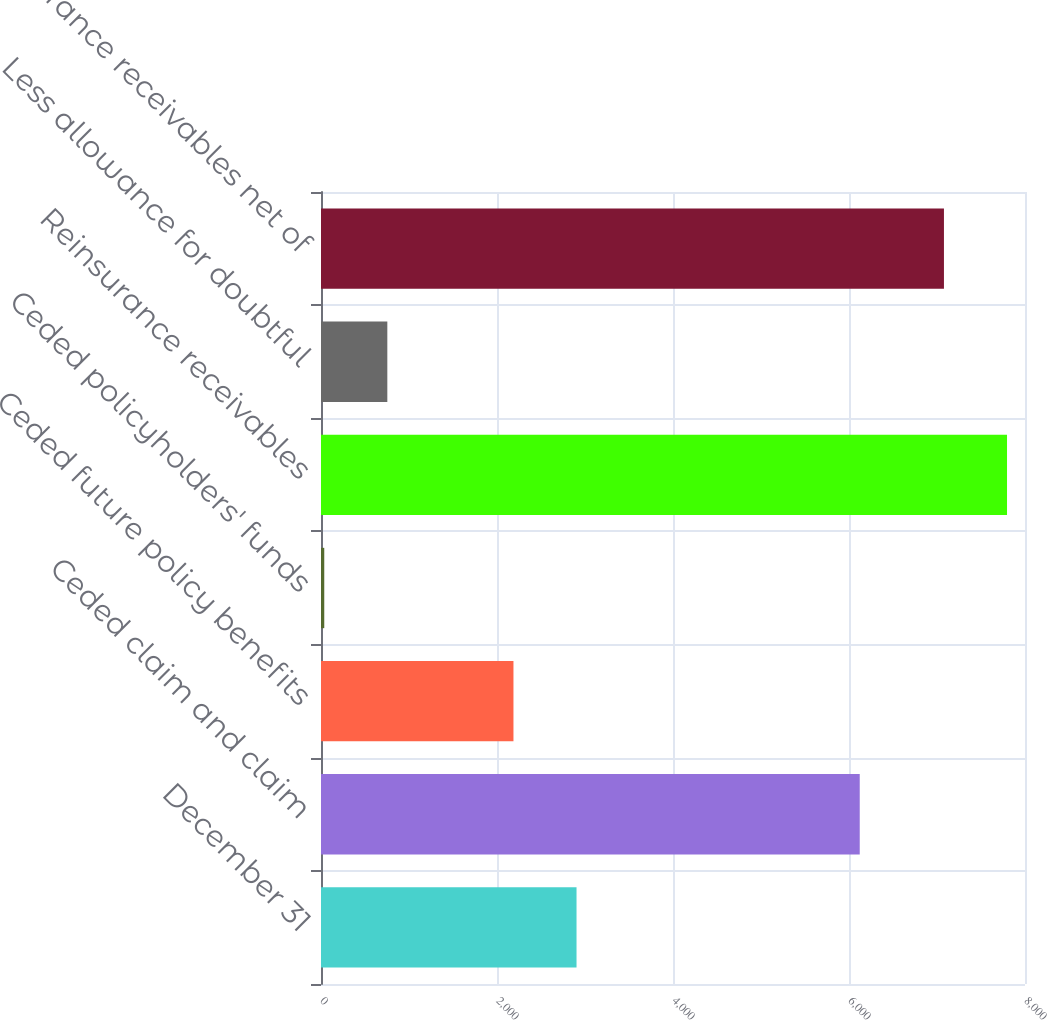Convert chart to OTSL. <chart><loc_0><loc_0><loc_500><loc_500><bar_chart><fcel>December 31<fcel>Ceded claim and claim<fcel>Ceded future policy benefits<fcel>Ceded policyholders' funds<fcel>Reinsurance receivables<fcel>Less allowance for doubtful<fcel>Reinsurance receivables net of<nl><fcel>2903.8<fcel>6122<fcel>2187.1<fcel>37<fcel>7795.7<fcel>753.7<fcel>7079<nl></chart> 